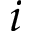Convert formula to latex. <formula><loc_0><loc_0><loc_500><loc_500>i</formula> 